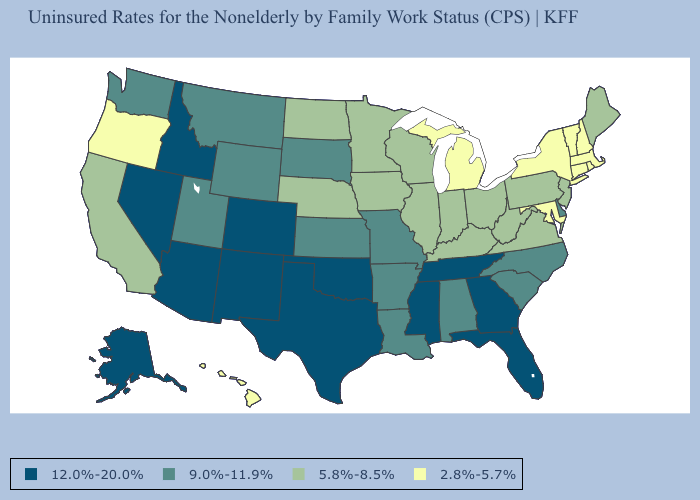What is the value of Louisiana?
Keep it brief. 9.0%-11.9%. What is the highest value in states that border Pennsylvania?
Quick response, please. 9.0%-11.9%. Among the states that border California , which have the highest value?
Short answer required. Arizona, Nevada. What is the value of Iowa?
Be succinct. 5.8%-8.5%. What is the highest value in the South ?
Concise answer only. 12.0%-20.0%. Is the legend a continuous bar?
Answer briefly. No. Name the states that have a value in the range 9.0%-11.9%?
Keep it brief. Alabama, Arkansas, Delaware, Kansas, Louisiana, Missouri, Montana, North Carolina, South Carolina, South Dakota, Utah, Washington, Wyoming. Does Kansas have the highest value in the MidWest?
Keep it brief. Yes. Name the states that have a value in the range 5.8%-8.5%?
Keep it brief. California, Illinois, Indiana, Iowa, Kentucky, Maine, Minnesota, Nebraska, New Jersey, North Dakota, Ohio, Pennsylvania, Virginia, West Virginia, Wisconsin. What is the highest value in states that border South Dakota?
Be succinct. 9.0%-11.9%. How many symbols are there in the legend?
Keep it brief. 4. How many symbols are there in the legend?
Write a very short answer. 4. What is the value of Texas?
Write a very short answer. 12.0%-20.0%. What is the value of Minnesota?
Be succinct. 5.8%-8.5%. 